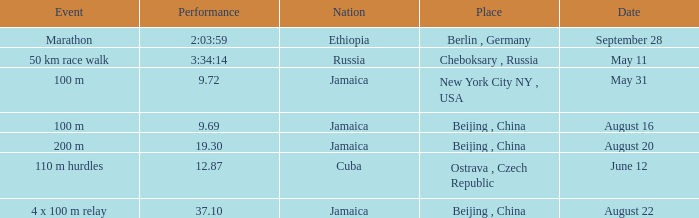Which nation ran a time of 9.69 seconds? Jamaica. 